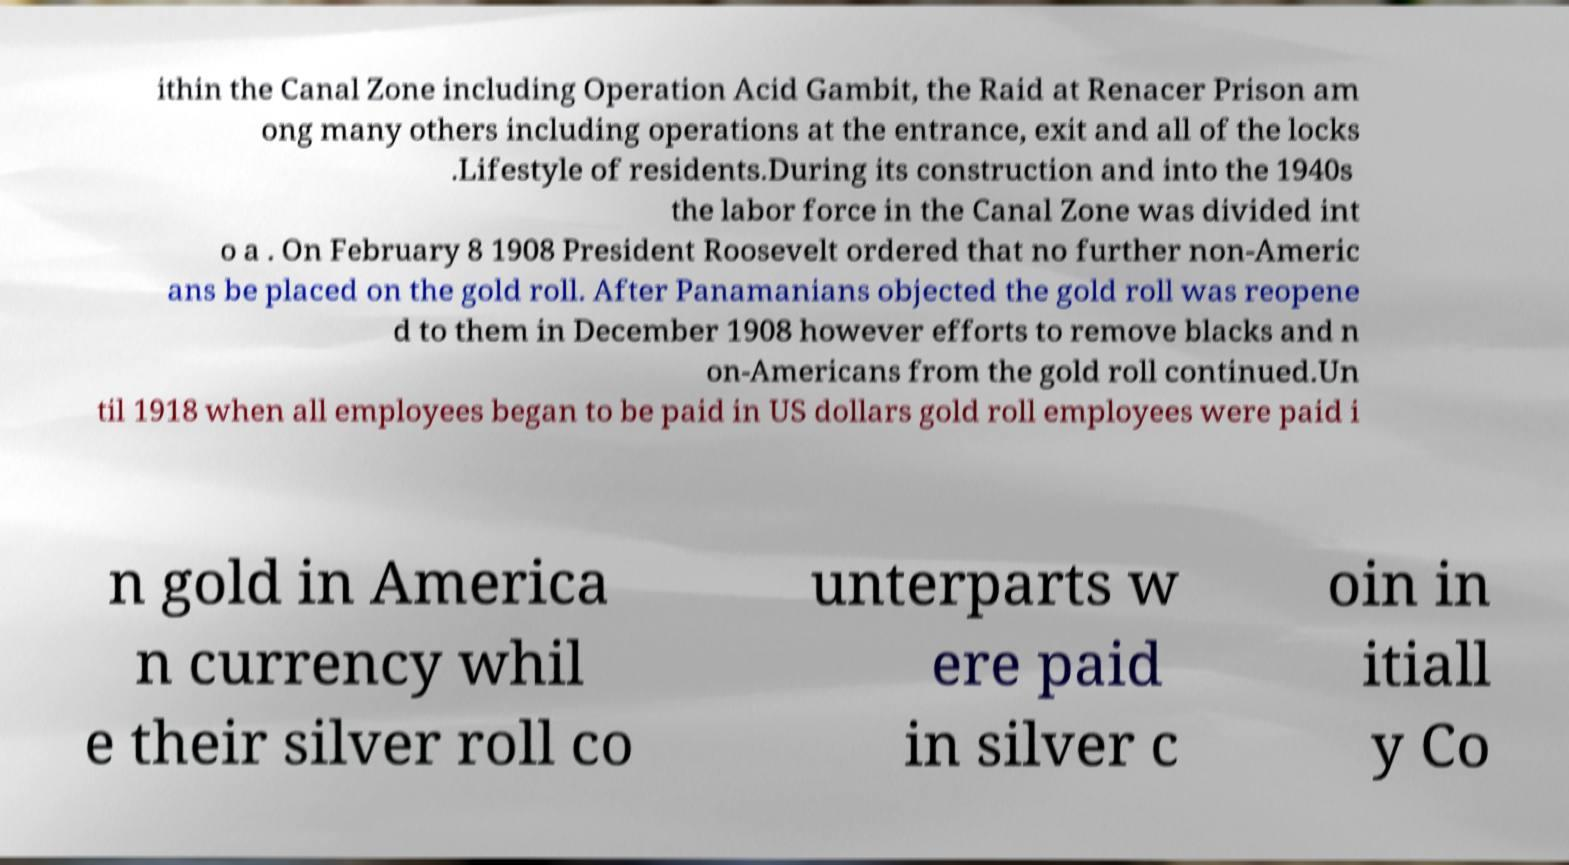There's text embedded in this image that I need extracted. Can you transcribe it verbatim? ithin the Canal Zone including Operation Acid Gambit, the Raid at Renacer Prison am ong many others including operations at the entrance, exit and all of the locks .Lifestyle of residents.During its construction and into the 1940s the labor force in the Canal Zone was divided int o a . On February 8 1908 President Roosevelt ordered that no further non-Americ ans be placed on the gold roll. After Panamanians objected the gold roll was reopene d to them in December 1908 however efforts to remove blacks and n on-Americans from the gold roll continued.Un til 1918 when all employees began to be paid in US dollars gold roll employees were paid i n gold in America n currency whil e their silver roll co unterparts w ere paid in silver c oin in itiall y Co 